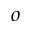Convert formula to latex. <formula><loc_0><loc_0><loc_500><loc_500>o</formula> 